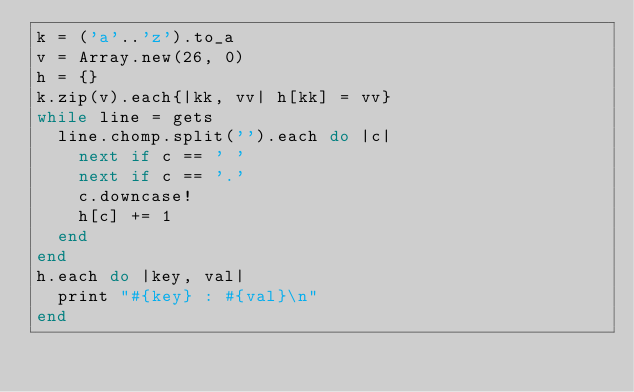<code> <loc_0><loc_0><loc_500><loc_500><_Ruby_>k = ('a'..'z').to_a
v = Array.new(26, 0)
h = {}
k.zip(v).each{|kk, vv| h[kk] = vv}
while line = gets
  line.chomp.split('').each do |c|
    next if c == ' '
    next if c == '.'
    c.downcase!
    h[c] += 1
  end
end
h.each do |key, val|
  print "#{key} : #{val}\n"
end</code> 